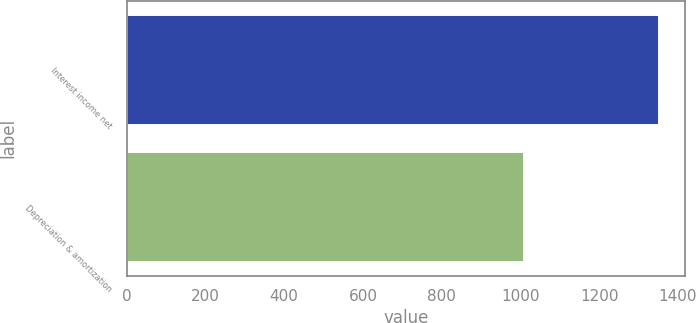Convert chart. <chart><loc_0><loc_0><loc_500><loc_500><bar_chart><fcel>Interest income net<fcel>Depreciation & amortization<nl><fcel>1351<fcel>1009<nl></chart> 